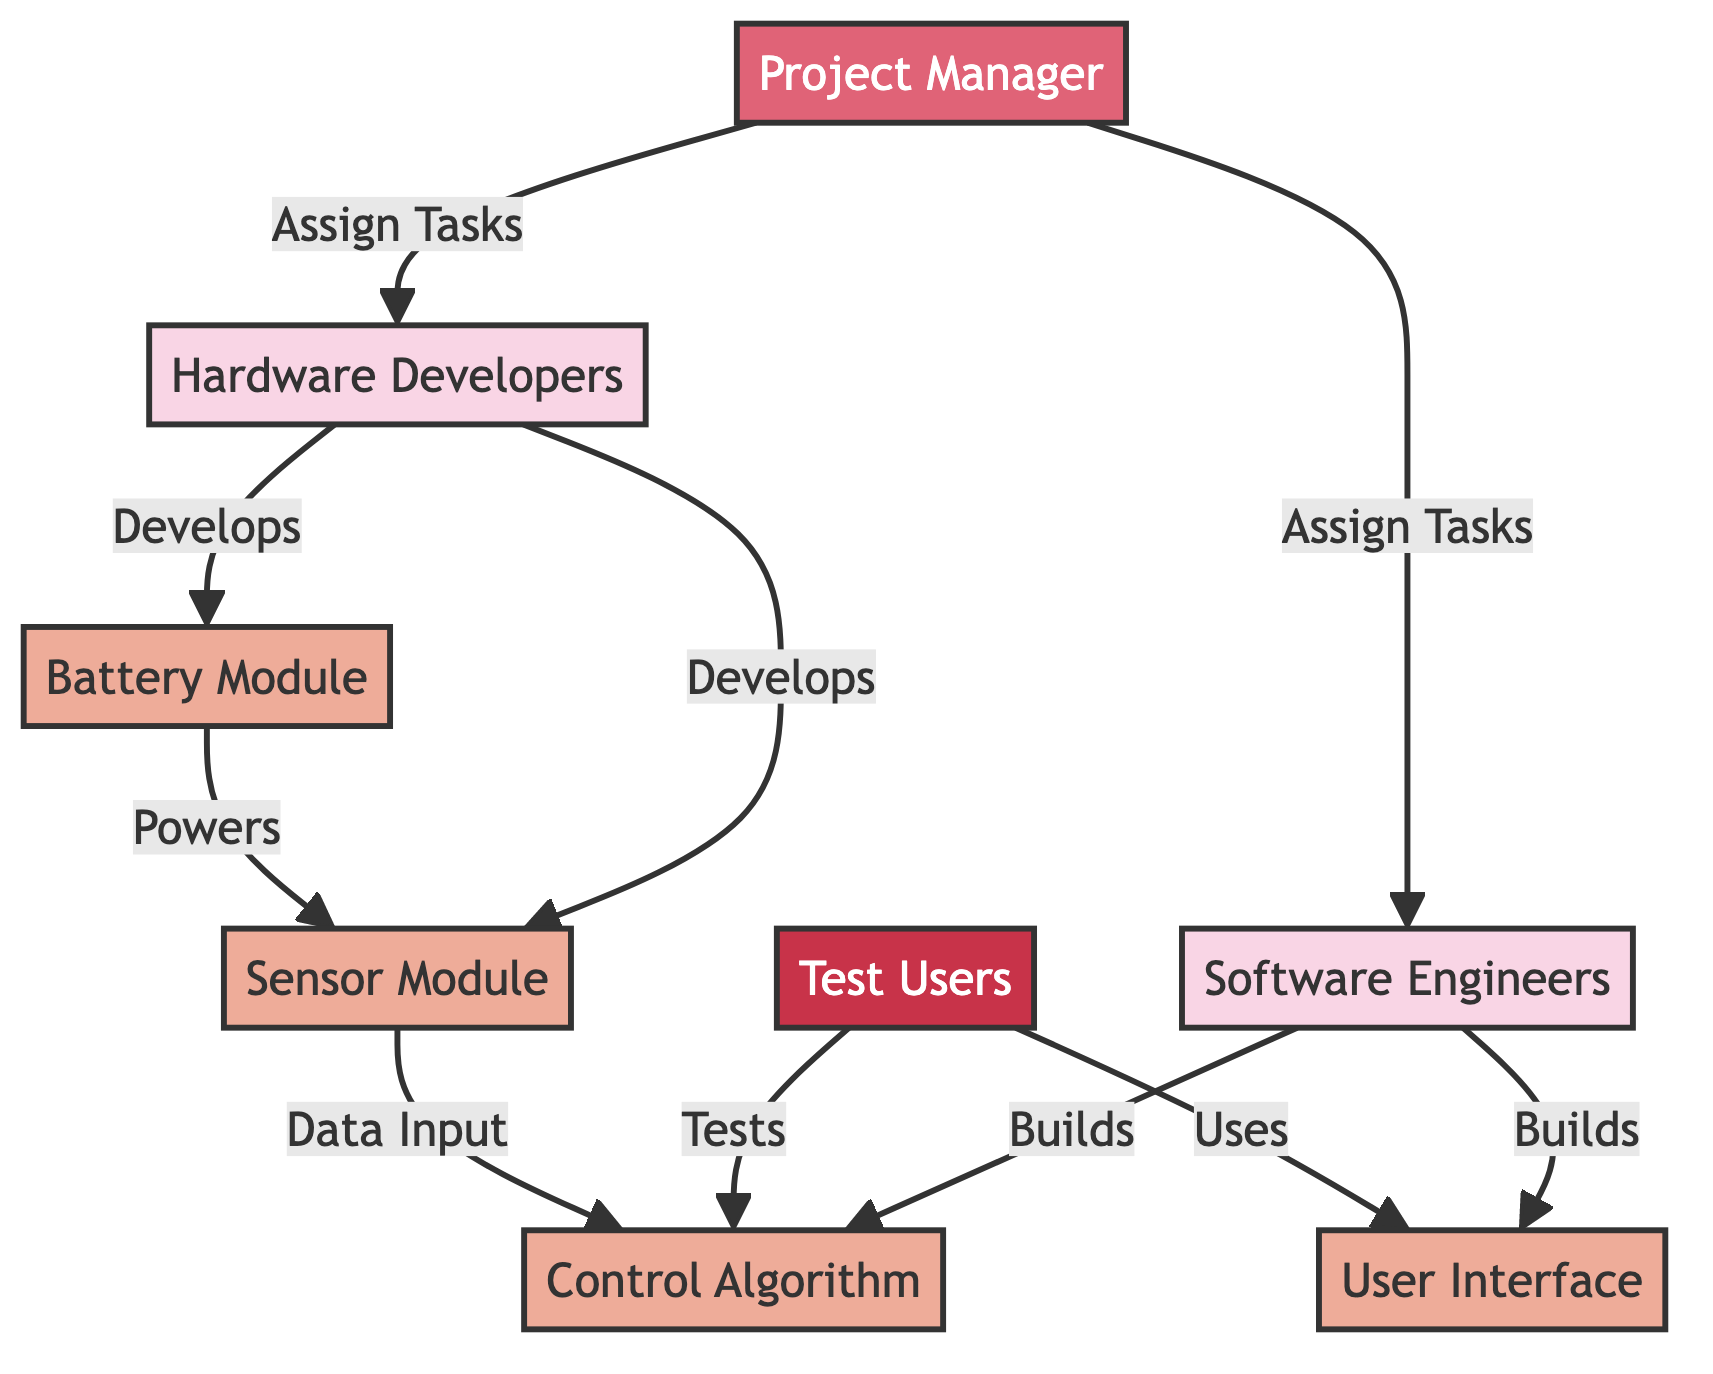What is the total number of nodes in the diagram? To find the total number of nodes, count each unique entry in the "nodes" list provided in the data. There are eight unique entries: Hardware Developers, Software Engineers, Project Manager, Test Users, Battery Module, Sensor Module, Control Algorithm, and User Interface.
Answer: 8 Who assigns tasks to the hardware developers? By analyzing the edges, we see that there is an edge from the Project Manager to Hardware Developers labeled "Assign Tasks". Therefore, it is the Project Manager who is responsible for assigning tasks to the hardware developers.
Answer: Project Manager Which component is developed by the hardware team? Looking at the edges connected to the hardware team, we find two labels: "Develops" followed by Battery Module and Sensor Module. This indicates that both of these components are developed by the hardware team.
Answer: Battery Module and Sensor Module How many components are tested by the test users? The test users have one edge connecting to the Control Algorithm (labeled "Tests") and one edge to the User Interface (labeled "Uses"). While they use the User Interface, it's the testing context that we are considering here, which totals one component tested directly.
Answer: 1 What powers the sensor module? According to the edges, there is a relationship from the Battery Module to the Sensor Module labeled "Powers". This indicates that the Battery Module supplies power to the Sensor Module.
Answer: Battery Module What is the relationship between the sensor module and the control algorithm? The diagram shows that the sensor module provides "Data Input" to the control algorithm, meaning it supplies necessary data for the control algorithm to function effectively.
Answer: Data Input Who builds the user interface? The software team has an edge leading to the User Interface labeled "Builds", indicating it is the responsibility of the software team to create or develop the user interface.
Answer: Software Engineers How many teams are involved in the diagram? The nodes indicate that there are three main teams: Hardware Developers, Software Engineers, and Test Users. Thus, counting these distinct teams gives us three.
Answer: 3 What type of diagram is this? The diagram represents a network of interrelated teams and components in a specific development context, showcasing the relationships and dependencies among them; hence, it is called a Collaboration Network Diagram.
Answer: Collaboration Network Diagram 